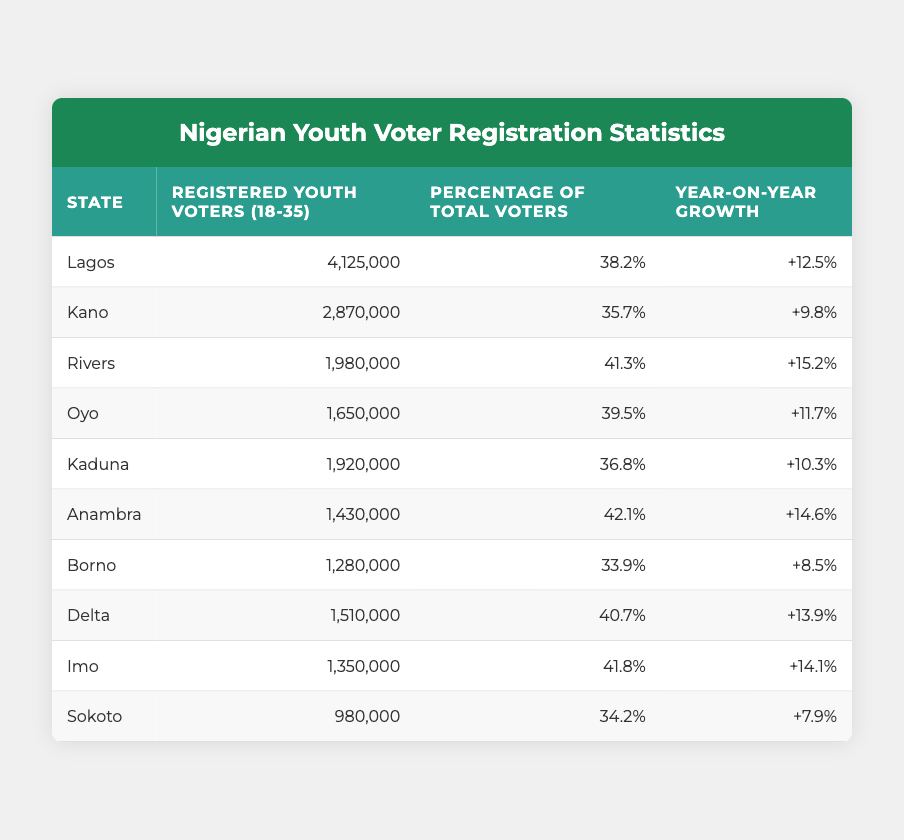What is the total number of registered youth voters in Lagos? The table shows that the number of registered youth voters in Lagos is 4,125,000. This value can be found directly in the second column of the row for Lagos.
Answer: 4,125,000 Which state has the highest percentage of youth voters? Upon examining the percentage column, Rivers has the highest percentage at 41.3%. This is the largest value compared to other states listed in the table.
Answer: 41.3% What is the year-on-year growth of registered youth voters in Anambra? Looking at the table, the year-on-year growth for Anambra is +14.6%. This value is found in the last column of the row corresponding to Anambra.
Answer: +14.6% How many more registered youth voters does Lagos have compared to Sokoto? Lagos has 4,125,000 voters and Sokoto has 980,000 voters. The difference is calculated as 4,125,000 - 980,000 = 3,145,000. This calculation shows how many more voters Lagos has than Sokoto.
Answer: 3,145,000 Is it true that Kaduna has a lower percentage of total voters than Borno? From the table, Kaduna has a percentage of 36.8% while Borno has a percentage of 33.9%. Since 36.8% is greater than 33.9%, the statement is false. Therefore, Kaduna does not have a lower percentage than Borno.
Answer: No Calculate the average number of registered youth voters for the states listed in the table. To find the average, we first sum the registered youth voters: 4,125,000 + 2,870,000 + 1,980,000 + 1,650,000 + 1,920,000 + 1,430,000 + 1,280,000 + 1,510,000 + 1,350,000 + 980,000 =  17,525,000. There are 10 states, so the average is 17,525,000 / 10 = 1,752,500.
Answer: 1,752,500 Which states have a year-on-year growth greater than 10%? By examining the year-on-year growth column, we can identify the states with growth rates of +12.5%, +15.2%, +11.7%, +10.3%, and +14.6%. These correspond to Lagos, Rivers, Oyo, Kaduna, and Anambra, respectively.
Answer: Lagos, Rivers, Oyo, Kaduna, Anambra Identify the state with the lowest registered youth voters among the listed. The table states that Sokoto has the lowest number of registered youth voters at 980,000, as this value is the smallest in the second column when compared to other states.
Answer: 980,000 